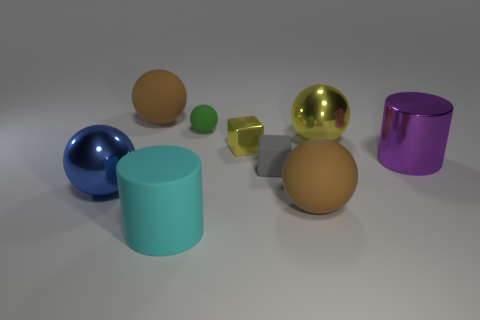Can you describe the different shapes present in the image? Certainly! The image contains various geometric shapes: there's a sphere, a cube, a cylinder, and a torus, also known as a donut shape.  Are there any objects that reflect light differently, and if so, why might that be? Yes, some objects in the image have different reflective properties. For instance, the golden sphere and the small gold block have a shiny, metallic finish that reflects light, suggesting they might be made of metal. Meanwhile, the brown sphere and the cylinder have a dull, matte finish that doesn't reflect much light, which could be indicative of a non-metallic material. 